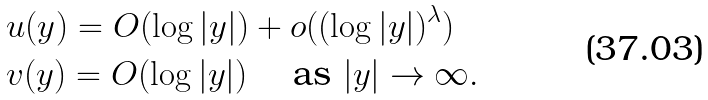Convert formula to latex. <formula><loc_0><loc_0><loc_500><loc_500>& u ( y ) = O ( \log | y | ) + o ( ( \log | y | ) ^ { \lambda } ) \\ & v ( y ) = O ( \log | y | ) \quad \text { as } | y | \to \infty .</formula> 